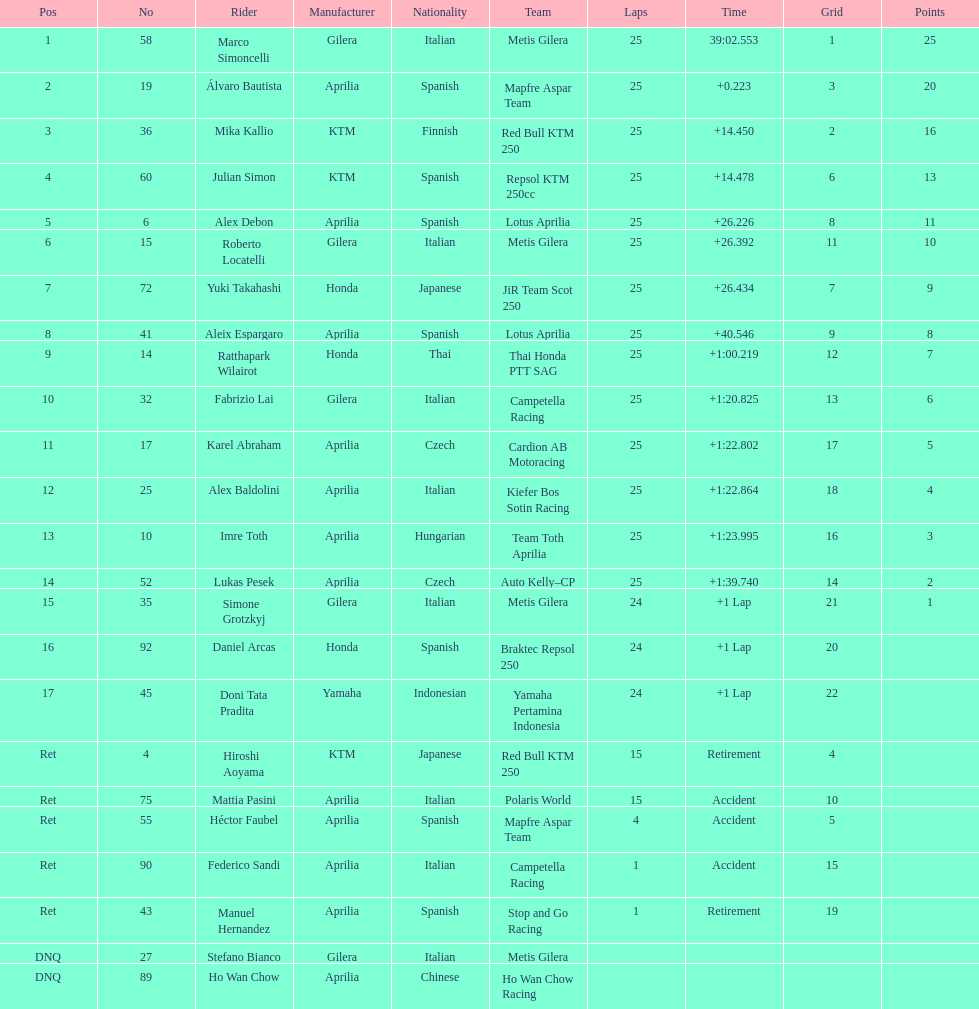What is the total number of rider? 24. Can you parse all the data within this table? {'header': ['Pos', 'No', 'Rider', 'Manufacturer', 'Nationality', 'Team', 'Laps', 'Time', 'Grid', 'Points'], 'rows': [['1', '58', 'Marco Simoncelli', 'Gilera', 'Italian', 'Metis Gilera', '25', '39:02.553', '1', '25'], ['2', '19', 'Álvaro Bautista', 'Aprilia', 'Spanish', 'Mapfre Aspar Team', '25', '+0.223', '3', '20'], ['3', '36', 'Mika Kallio', 'KTM', 'Finnish', 'Red Bull KTM 250', '25', '+14.450', '2', '16'], ['4', '60', 'Julian Simon', 'KTM', 'Spanish', 'Repsol KTM 250cc', '25', '+14.478', '6', '13'], ['5', '6', 'Alex Debon', 'Aprilia', 'Spanish', 'Lotus Aprilia', '25', '+26.226', '8', '11'], ['6', '15', 'Roberto Locatelli', 'Gilera', 'Italian', 'Metis Gilera', '25', '+26.392', '11', '10'], ['7', '72', 'Yuki Takahashi', 'Honda', 'Japanese', 'JiR Team Scot 250', '25', '+26.434', '7', '9'], ['8', '41', 'Aleix Espargaro', 'Aprilia', 'Spanish', 'Lotus Aprilia', '25', '+40.546', '9', '8'], ['9', '14', 'Ratthapark Wilairot', 'Honda', 'Thai', 'Thai Honda PTT SAG', '25', '+1:00.219', '12', '7'], ['10', '32', 'Fabrizio Lai', 'Gilera', 'Italian', 'Campetella Racing', '25', '+1:20.825', '13', '6'], ['11', '17', 'Karel Abraham', 'Aprilia', 'Czech', 'Cardion AB Motoracing', '25', '+1:22.802', '17', '5'], ['12', '25', 'Alex Baldolini', 'Aprilia', 'Italian', 'Kiefer Bos Sotin Racing', '25', '+1:22.864', '18', '4'], ['13', '10', 'Imre Toth', 'Aprilia', 'Hungarian', 'Team Toth Aprilia', '25', '+1:23.995', '16', '3'], ['14', '52', 'Lukas Pesek', 'Aprilia', 'Czech', 'Auto Kelly–CP', '25', '+1:39.740', '14', '2'], ['15', '35', 'Simone Grotzkyj', 'Gilera', 'Italian', 'Metis Gilera', '24', '+1 Lap', '21', '1'], ['16', '92', 'Daniel Arcas', 'Honda', 'Spanish', 'Braktec Repsol 250', '24', '+1 Lap', '20', ''], ['17', '45', 'Doni Tata Pradita', 'Yamaha', 'Indonesian', 'Yamaha Pertamina Indonesia', '24', '+1 Lap', '22', ''], ['Ret', '4', 'Hiroshi Aoyama', 'KTM', 'Japanese', 'Red Bull KTM 250', '15', 'Retirement', '4', ''], ['Ret', '75', 'Mattia Pasini', 'Aprilia', 'Italian', 'Polaris World', '15', 'Accident', '10', ''], ['Ret', '55', 'Héctor Faubel', 'Aprilia', 'Spanish', 'Mapfre Aspar Team', '4', 'Accident', '5', ''], ['Ret', '90', 'Federico Sandi', 'Aprilia', 'Italian', 'Campetella Racing', '1', 'Accident', '15', ''], ['Ret', '43', 'Manuel Hernandez', 'Aprilia', 'Spanish', 'Stop and Go Racing', '1', 'Retirement', '19', ''], ['DNQ', '27', 'Stefano Bianco', 'Gilera', 'Italian', 'Metis Gilera', '', '', '', ''], ['DNQ', '89', 'Ho Wan Chow', 'Aprilia', 'Chinese', 'Ho Wan Chow Racing', '', '', '', '']]} 